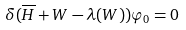<formula> <loc_0><loc_0><loc_500><loc_500>\delta ( \overline { H } + W - \lambda ( W ) ) \varphi _ { 0 } = 0</formula> 